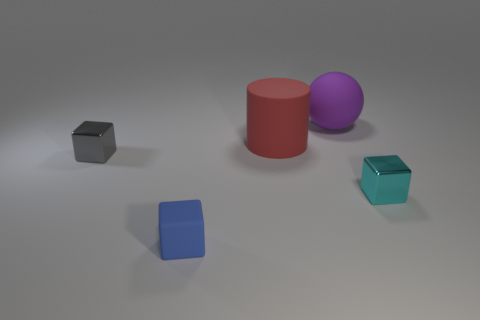Can you tell me the colors of the cubes and their respective positions in the image? Certainly! In the image, there are three cubes. Starting from the left, the first cube is gray and it's positioned on the far left side by itself. The second cube is blue, located somewhat near the center but more towards the front of the image. The third cube is a shiny teal color, situated on the right side, slightly behind the purple sphere. 